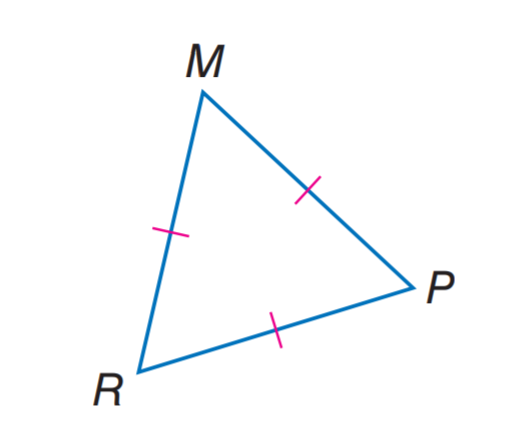Answer the mathemtical geometry problem and directly provide the correct option letter.
Question: Find m \angle M R P.
Choices: A: 40 B: 50 C: 60 D: 80 C 